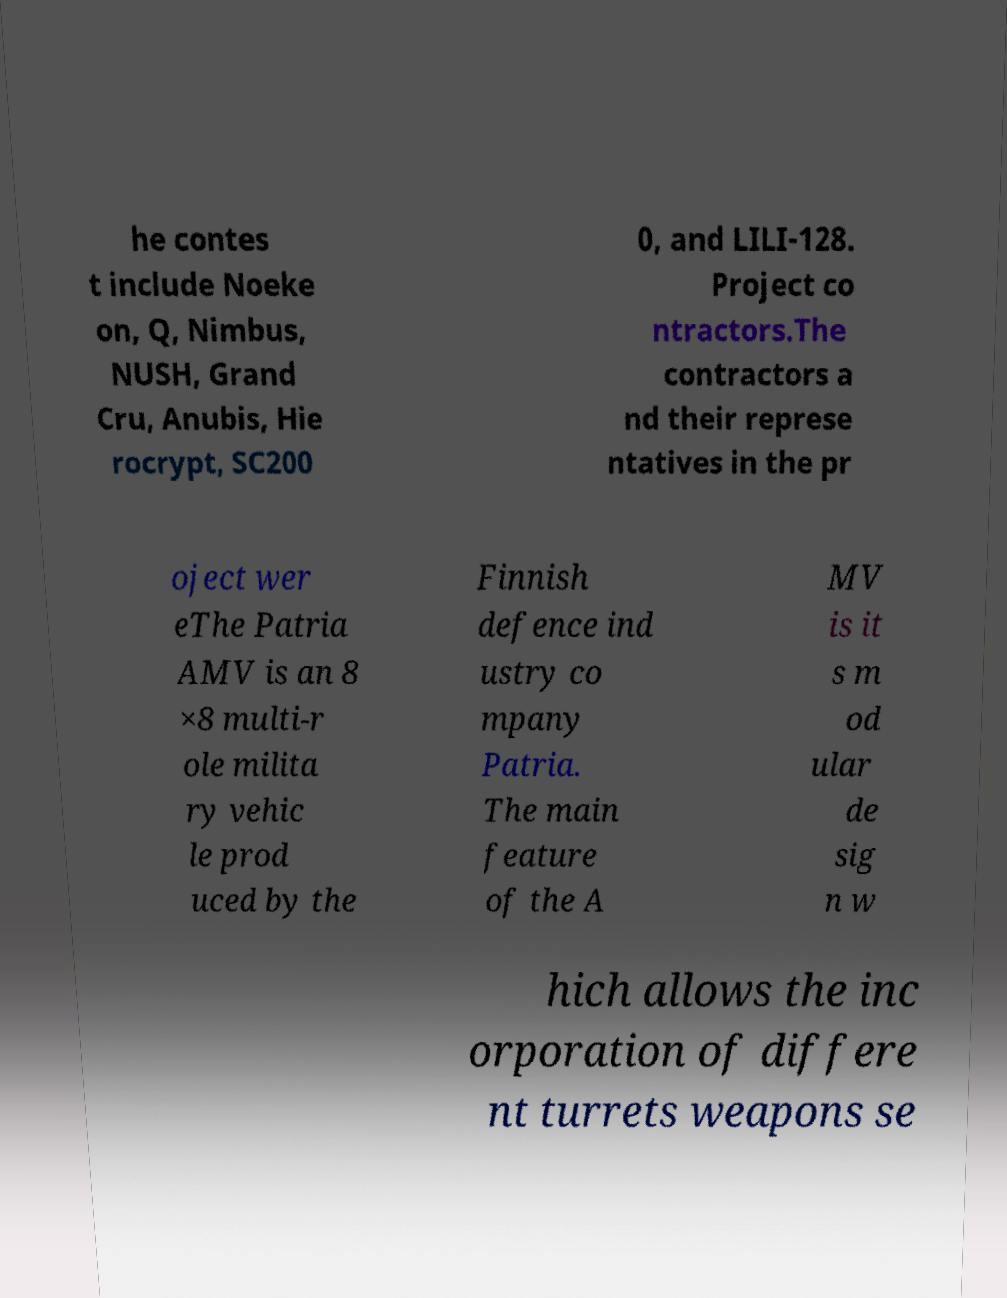I need the written content from this picture converted into text. Can you do that? he contes t include Noeke on, Q, Nimbus, NUSH, Grand Cru, Anubis, Hie rocrypt, SC200 0, and LILI-128. Project co ntractors.The contractors a nd their represe ntatives in the pr oject wer eThe Patria AMV is an 8 ×8 multi-r ole milita ry vehic le prod uced by the Finnish defence ind ustry co mpany Patria. The main feature of the A MV is it s m od ular de sig n w hich allows the inc orporation of differe nt turrets weapons se 